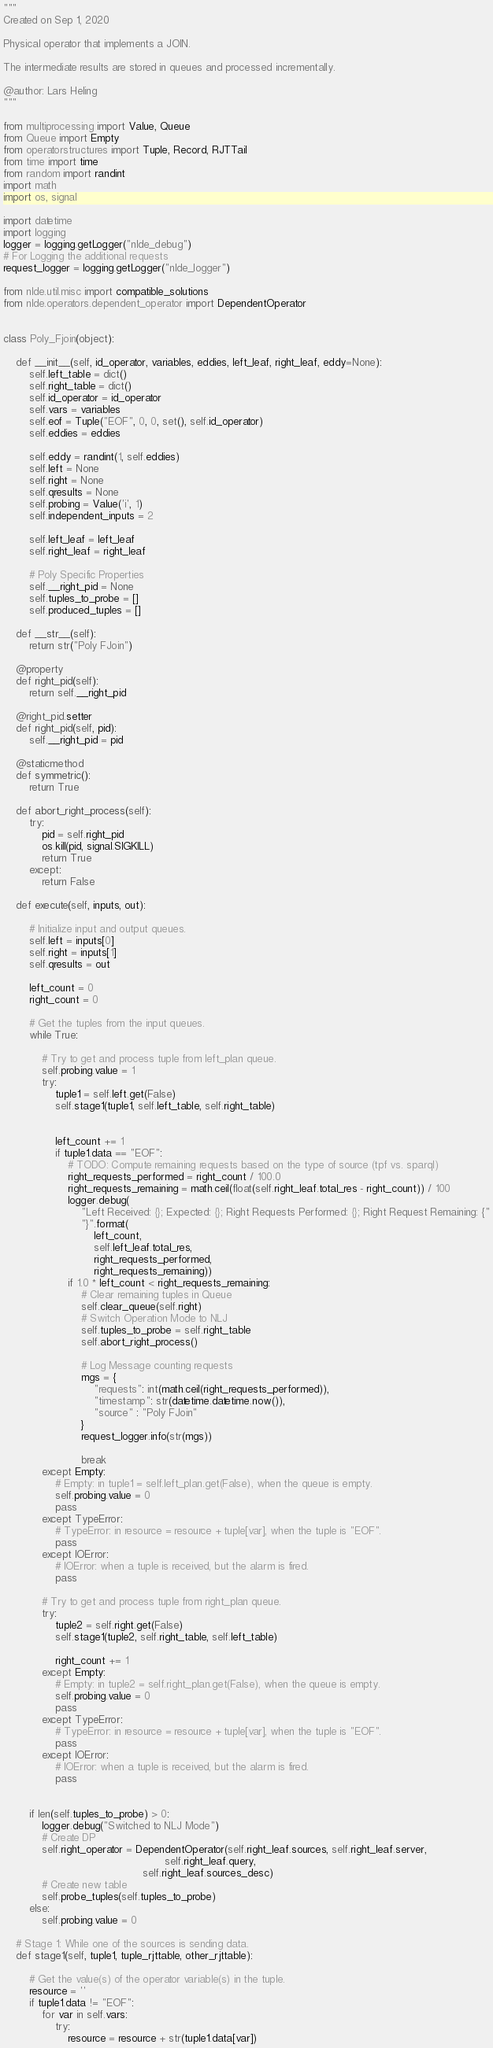Convert code to text. <code><loc_0><loc_0><loc_500><loc_500><_Python_>"""
Created on Sep 1, 2020

Physical operator that implements a JOIN.

The intermediate results are stored in queues and processed incrementally.

@author: Lars Heling
"""

from multiprocessing import Value, Queue
from Queue import Empty
from operatorstructures import Tuple, Record, RJTTail
from time import time
from random import randint
import math
import os, signal

import datetime
import logging
logger = logging.getLogger("nlde_debug")
# For Logging the additional requests
request_logger = logging.getLogger("nlde_logger")

from nlde.util.misc import compatible_solutions
from nlde.operators.dependent_operator import DependentOperator


class Poly_Fjoin(object):

    def __init__(self, id_operator, variables, eddies, left_leaf, right_leaf, eddy=None):
        self.left_table = dict()
        self.right_table = dict()
        self.id_operator = id_operator
        self.vars = variables
        self.eof = Tuple("EOF", 0, 0, set(), self.id_operator)
        self.eddies = eddies

        self.eddy = randint(1, self.eddies)
        self.left = None
        self.right = None
        self.qresults = None
        self.probing = Value('i', 1)
        self.independent_inputs = 2

        self.left_leaf = left_leaf
        self.right_leaf = right_leaf

        # Poly Specific Properties
        self.__right_pid = None
        self.tuples_to_probe = []
        self.produced_tuples = []

    def __str__(self):
        return str("Poly FJoin")

    @property
    def right_pid(self):
        return self.__right_pid

    @right_pid.setter
    def right_pid(self, pid):
        self.__right_pid = pid

    @staticmethod
    def symmetric():
        return True

    def abort_right_process(self):
        try:
            pid = self.right_pid
            os.kill(pid, signal.SIGKILL)
            return True
        except:
            return False

    def execute(self, inputs, out):

        # Initialize input and output queues.
        self.left = inputs[0]
        self.right = inputs[1]
        self.qresults = out

        left_count = 0
        right_count = 0

        # Get the tuples from the input queues.
        while True:

            # Try to get and process tuple from left_plan queue.
            self.probing.value = 1
            try:
                tuple1 = self.left.get(False)
                self.stage1(tuple1, self.left_table, self.right_table)


                left_count += 1
                if tuple1.data == "EOF":
                    # TODO: Compute remaining requests based on the type of source (tpf vs. sparql)
                    right_requests_performed = right_count / 100.0
                    right_requests_remaining = math.ceil(float(self.right_leaf.total_res - right_count)) / 100
                    logger.debug(
                        "Left Received: {}; Expected: {}; Right Requests Performed: {}; Right Request Remaining: {"
                        "}".format(
                            left_count,
                            self.left_leaf.total_res,
                            right_requests_performed,
                            right_requests_remaining))
                    if 1.0 * left_count < right_requests_remaining:
                        # Clear remaining tuples in Queue
                        self.clear_queue(self.right)
                        # Switch Operation Mode to NLJ
                        self.tuples_to_probe = self.right_table
                        self.abort_right_process()

                        # Log Message counting requests
                        mgs = {
                            "requests": int(math.ceil(right_requests_performed)),
                            "timestamp": str(datetime.datetime.now()),
                            "source" : "Poly FJoin"
                        }
                        request_logger.info(str(mgs))

                        break
            except Empty:
                # Empty: in tuple1 = self.left_plan.get(False), when the queue is empty.
                self.probing.value = 0
                pass
            except TypeError:
                # TypeError: in resource = resource + tuple[var], when the tuple is "EOF".
                pass
            except IOError:
                # IOError: when a tuple is received, but the alarm is fired.
                pass

            # Try to get and process tuple from right_plan queue.
            try:
                tuple2 = self.right.get(False)
                self.stage1(tuple2, self.right_table, self.left_table)

                right_count += 1
            except Empty:
                # Empty: in tuple2 = self.right_plan.get(False), when the queue is empty.
                self.probing.value = 0
                pass
            except TypeError:
                # TypeError: in resource = resource + tuple[var], when the tuple is "EOF".
                pass
            except IOError:
                # IOError: when a tuple is received, but the alarm is fired.
                pass


        if len(self.tuples_to_probe) > 0:
            logger.debug("Switched to NLJ Mode")
            # Create DP
            self.right_operator = DependentOperator(self.right_leaf.sources, self.right_leaf.server,
                                                  self.right_leaf.query,
                                           self.right_leaf.sources_desc)
            # Create new table
            self.probe_tuples(self.tuples_to_probe)
        else:
            self.probing.value = 0

    # Stage 1: While one of the sources is sending data.
    def stage1(self, tuple1, tuple_rjttable, other_rjttable):

        # Get the value(s) of the operator variable(s) in the tuple.
        resource = ''
        if tuple1.data != "EOF":
            for var in self.vars:
                try:
                    resource = resource + str(tuple1.data[var])</code> 